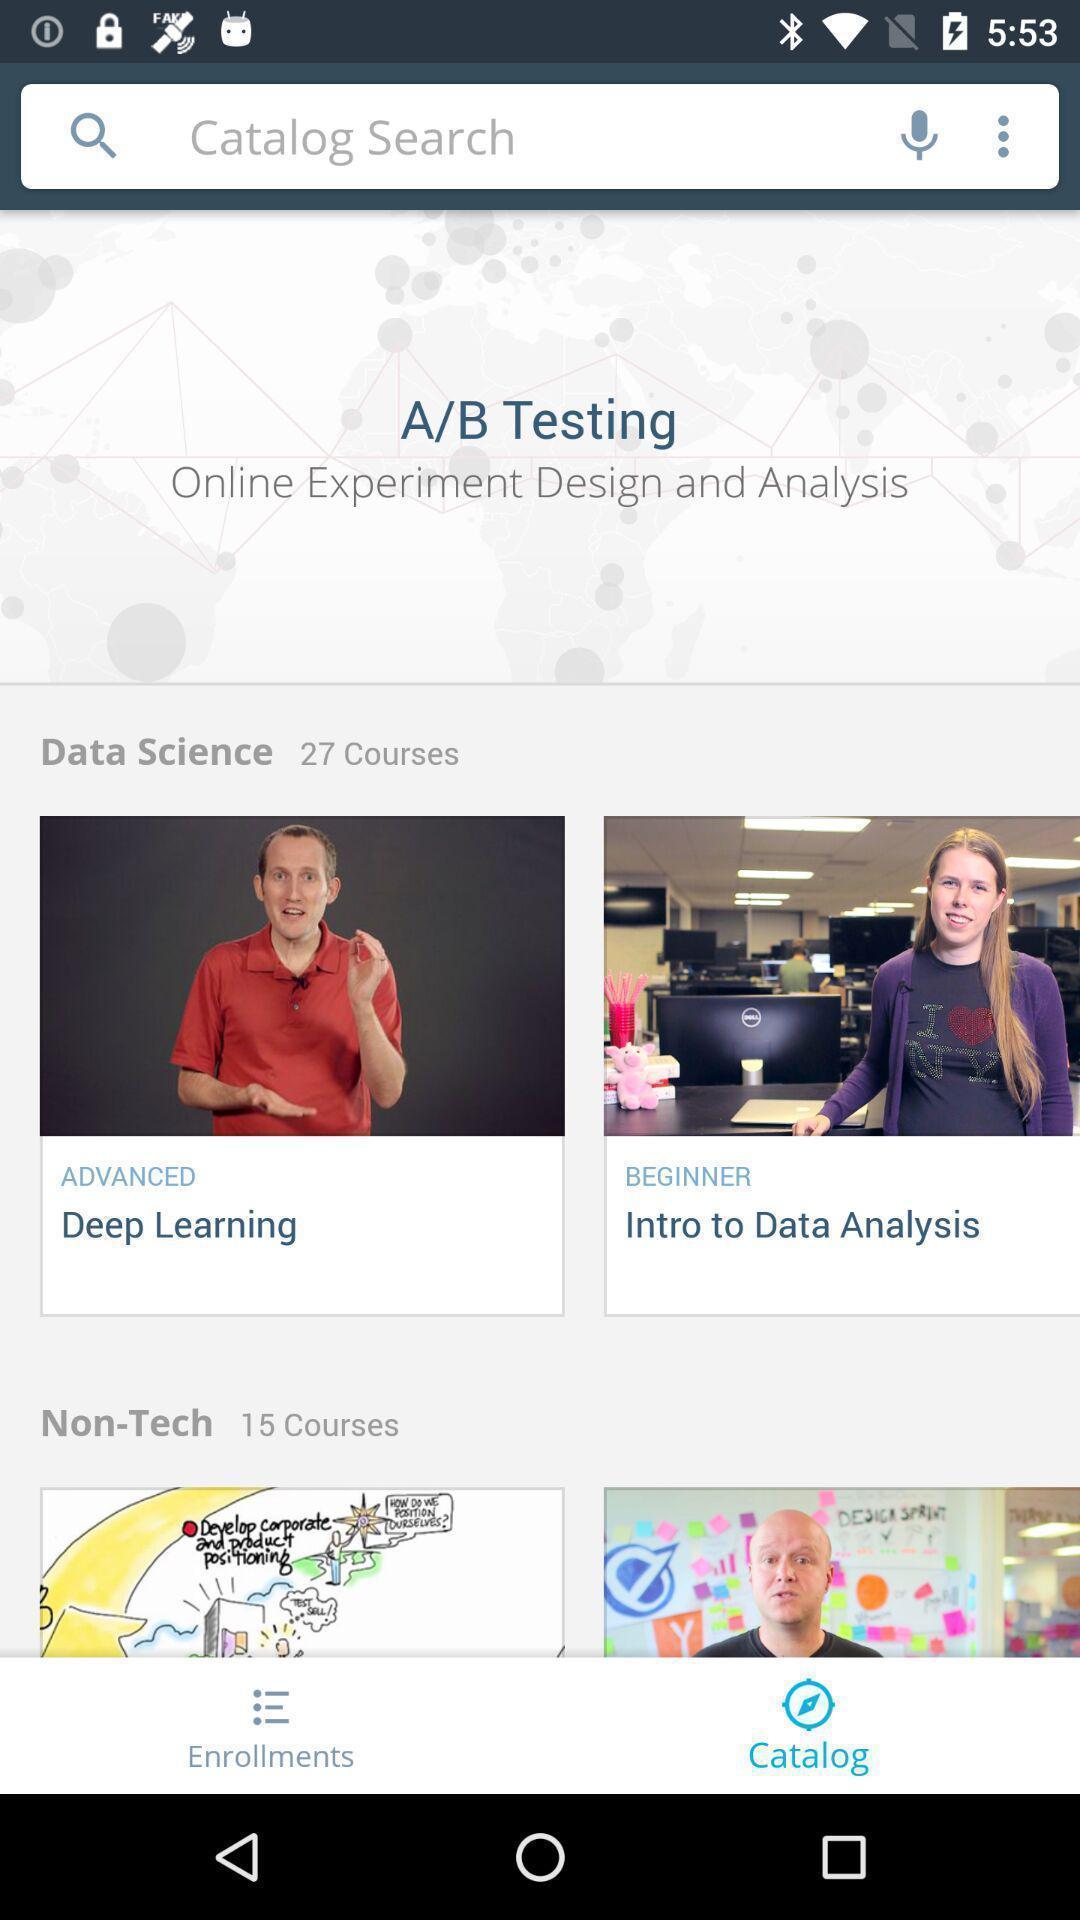Describe this image in words. Screen shows about a catalog search. 